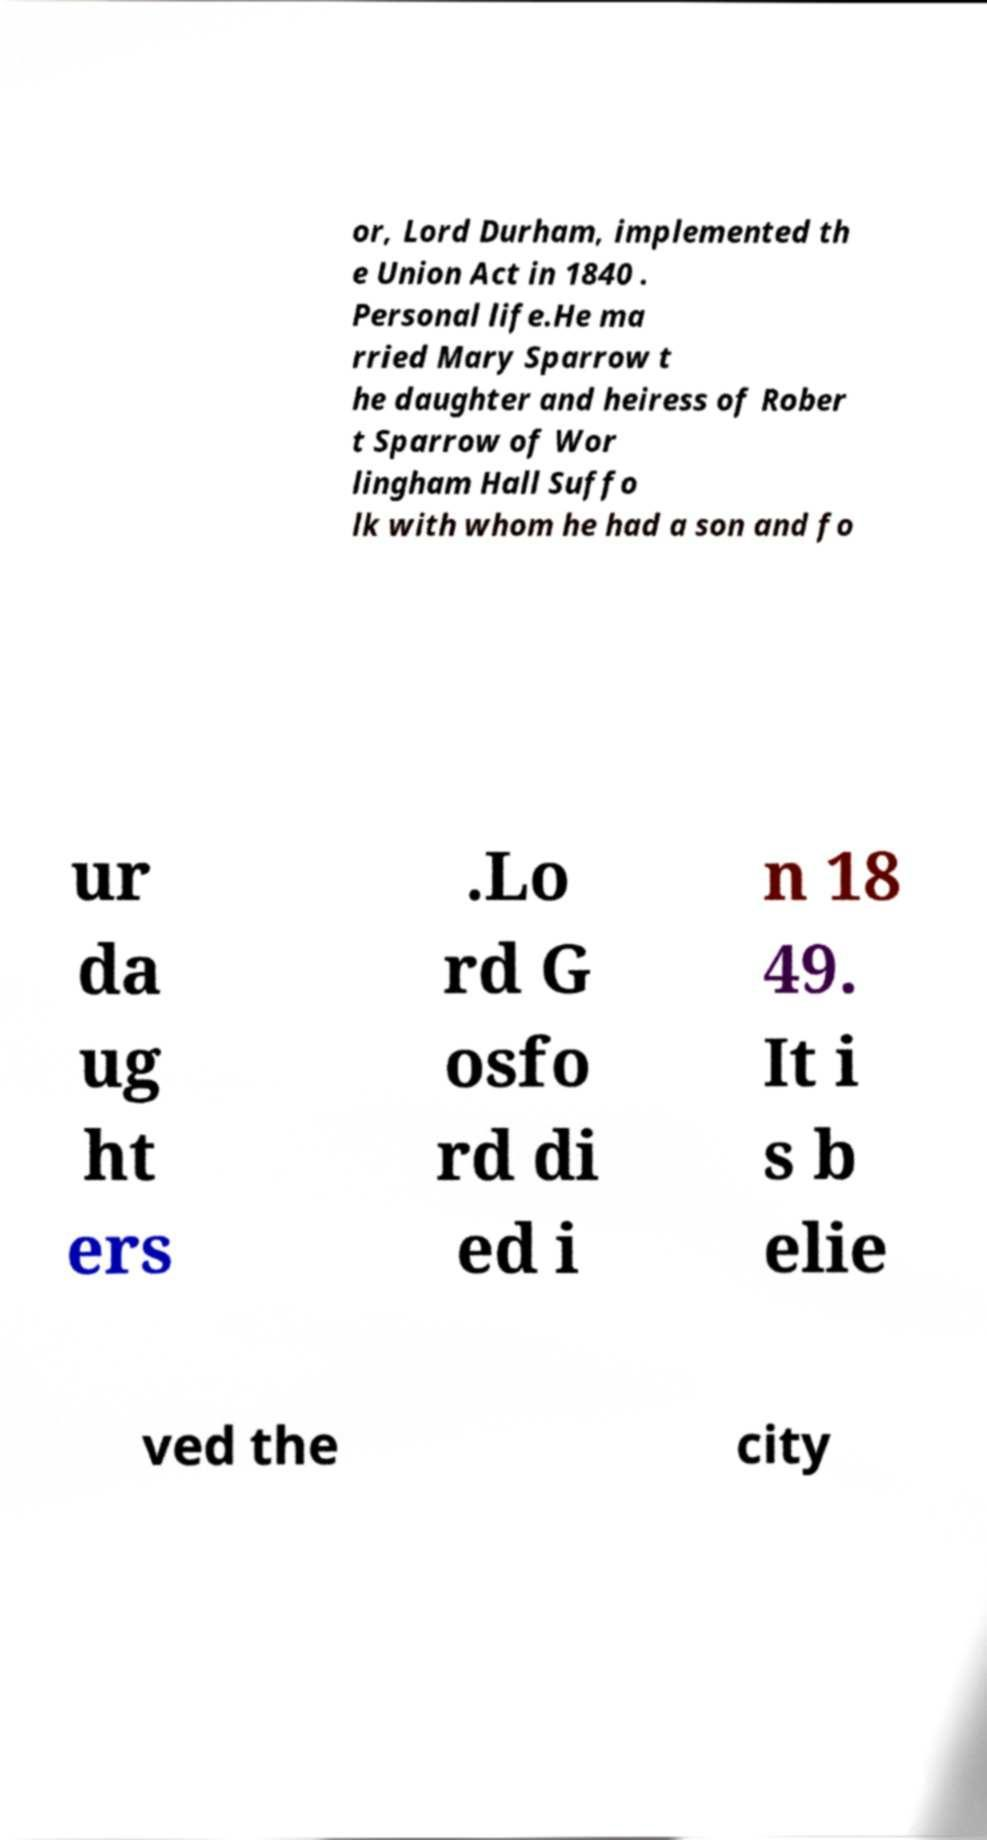Can you accurately transcribe the text from the provided image for me? or, Lord Durham, implemented th e Union Act in 1840 . Personal life.He ma rried Mary Sparrow t he daughter and heiress of Rober t Sparrow of Wor lingham Hall Suffo lk with whom he had a son and fo ur da ug ht ers .Lo rd G osfo rd di ed i n 18 49. It i s b elie ved the city 